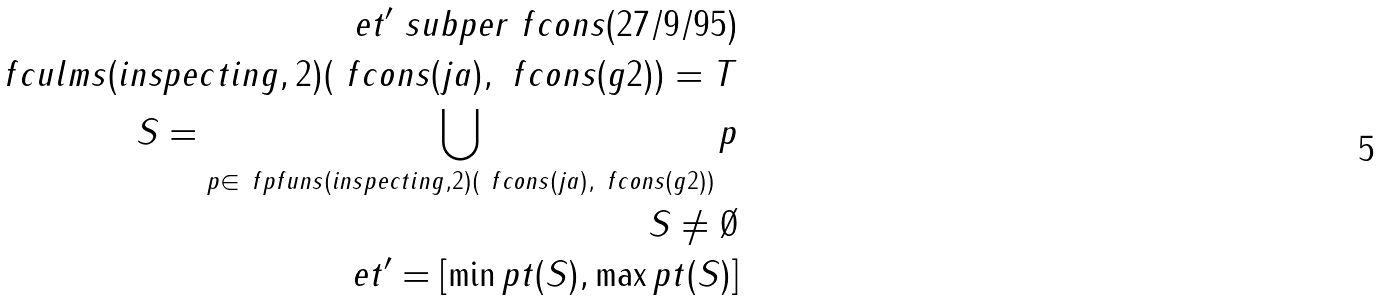<formula> <loc_0><loc_0><loc_500><loc_500>e t ^ { \prime } \ s u b p e r \ f c o n s ( 2 7 / 9 / 9 5 ) \\ \ f c u l m s ( i n s p e c t i n g , 2 ) ( \ f c o n s ( j a ) , \ f c o n s ( g 2 ) ) = T \\ S = \bigcup _ { p \in \ f p f u n s ( i n s p e c t i n g , 2 ) ( \ f c o n s ( j a ) , \ f c o n s ( g 2 ) ) } p \\ S \not = \emptyset \\ e t ^ { \prime } = [ \min p t ( S ) , \max p t ( S ) ]</formula> 